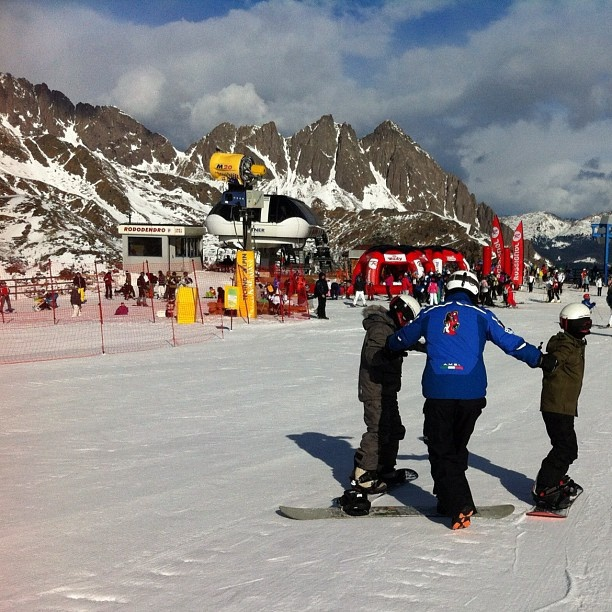Describe the objects in this image and their specific colors. I can see people in gray, black, navy, darkblue, and darkgray tones, people in gray, black, and darkgray tones, people in gray, black, darkgray, beige, and maroon tones, people in gray, black, maroon, and darkgray tones, and snowboard in gray, black, and darkgray tones in this image. 